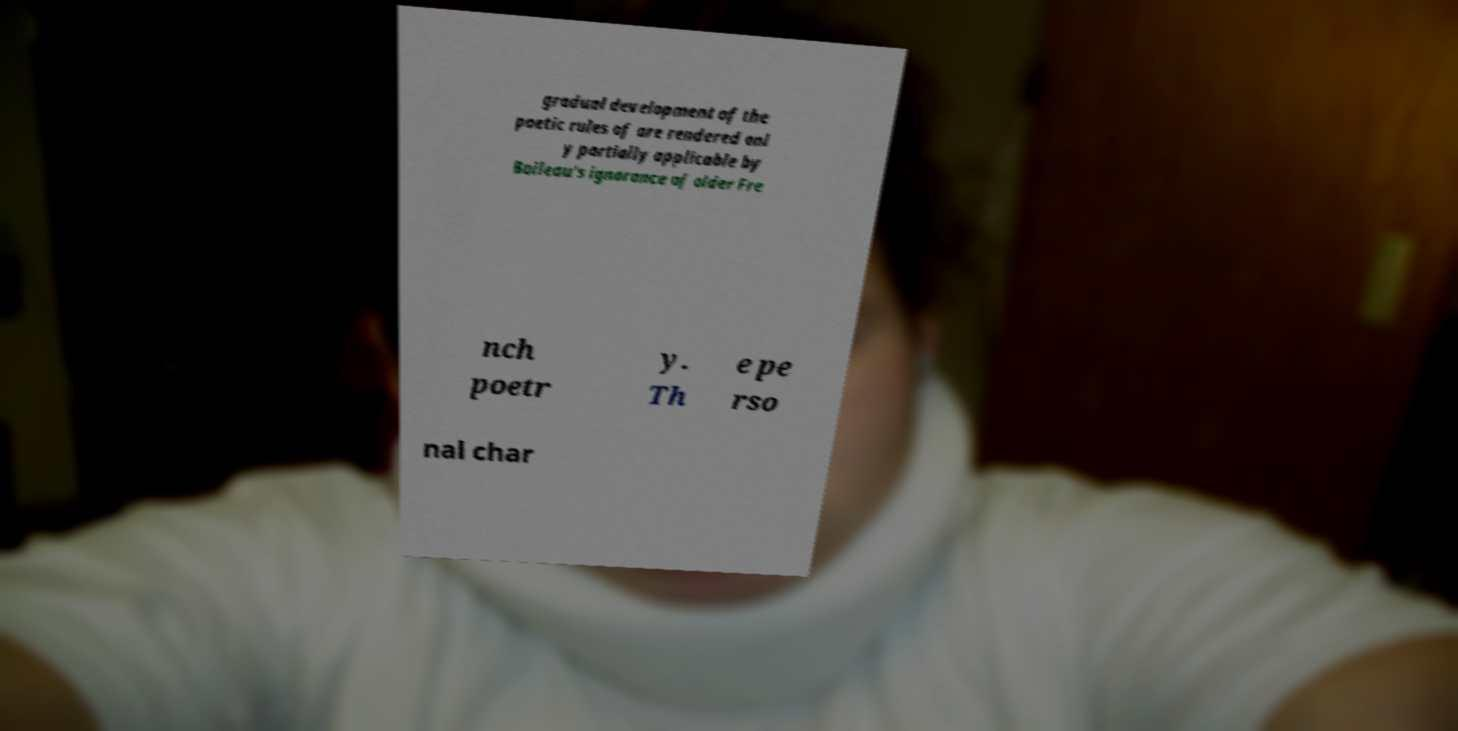Please read and relay the text visible in this image. What does it say? gradual development of the poetic rules of are rendered onl y partially applicable by Boileau's ignorance of older Fre nch poetr y. Th e pe rso nal char 